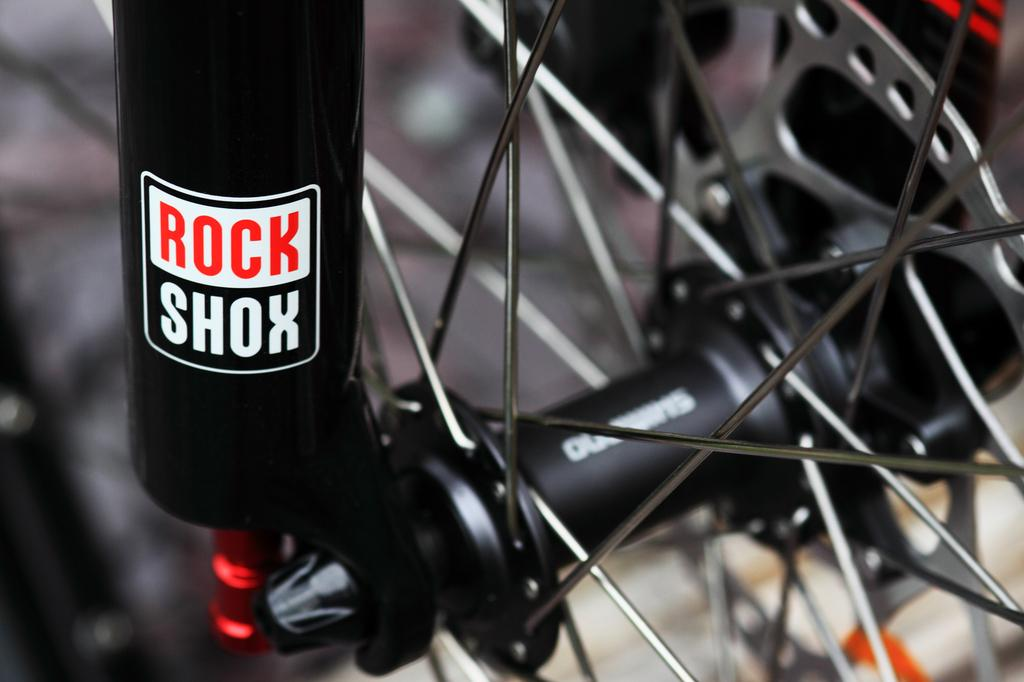What is the main subject of the image? The main subject of the image is a wheel of a vehicle. Can you describe any additional objects or features related to the wheel? Yes, there is a black object attached to the wheel. What type of action is taking place in the cellar in the image? There is no cellar or action present in the image; it only features a wheel of a vehicle with a black object attached to it. 